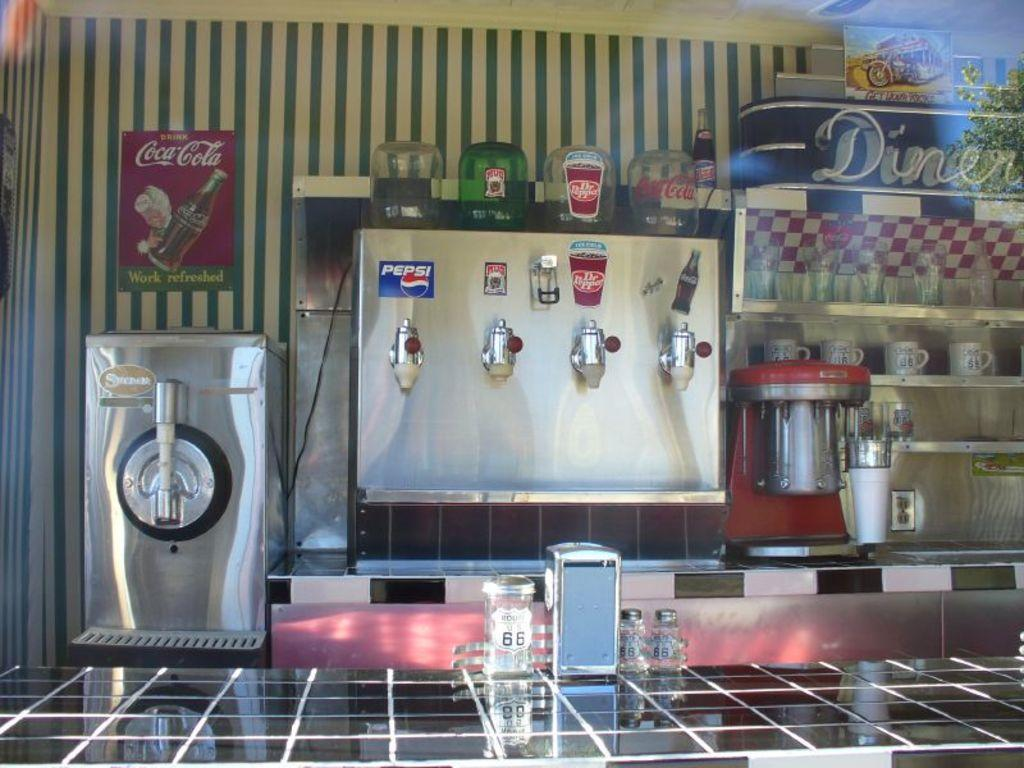Provide a one-sentence caption for the provided image. Diner showing a soda machine along the counter. 